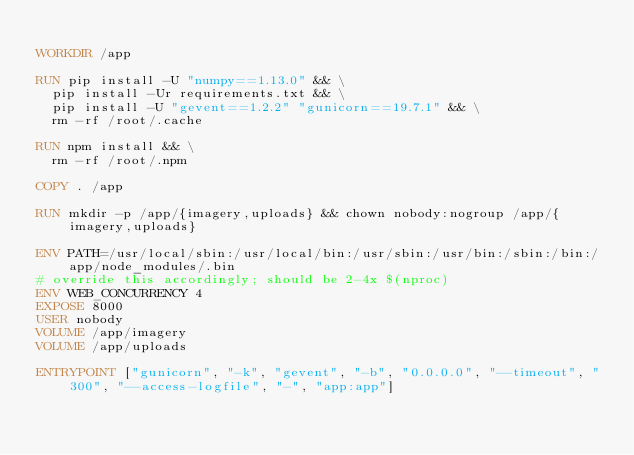Convert code to text. <code><loc_0><loc_0><loc_500><loc_500><_Dockerfile_>
WORKDIR /app

RUN pip install -U "numpy==1.13.0" && \
  pip install -Ur requirements.txt && \
  pip install -U "gevent==1.2.2" "gunicorn==19.7.1" && \
  rm -rf /root/.cache

RUN npm install && \
  rm -rf /root/.npm

COPY . /app

RUN mkdir -p /app/{imagery,uploads} && chown nobody:nogroup /app/{imagery,uploads}

ENV PATH=/usr/local/sbin:/usr/local/bin:/usr/sbin:/usr/bin:/sbin:/bin:/app/node_modules/.bin
# override this accordingly; should be 2-4x $(nproc)
ENV WEB_CONCURRENCY 4
EXPOSE 8000
USER nobody
VOLUME /app/imagery
VOLUME /app/uploads

ENTRYPOINT ["gunicorn", "-k", "gevent", "-b", "0.0.0.0", "--timeout", "300", "--access-logfile", "-", "app:app"]
</code> 